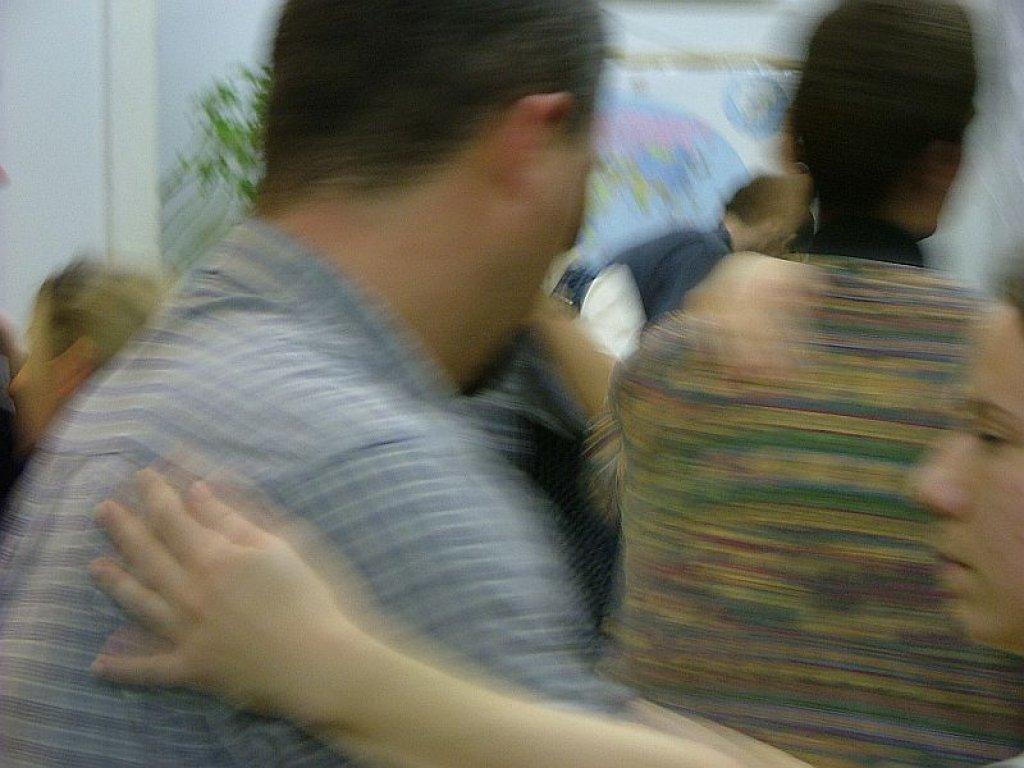In one or two sentences, can you explain what this image depicts? In the picture I can see a blur image which has few persons standing and there is a plant in the background. 